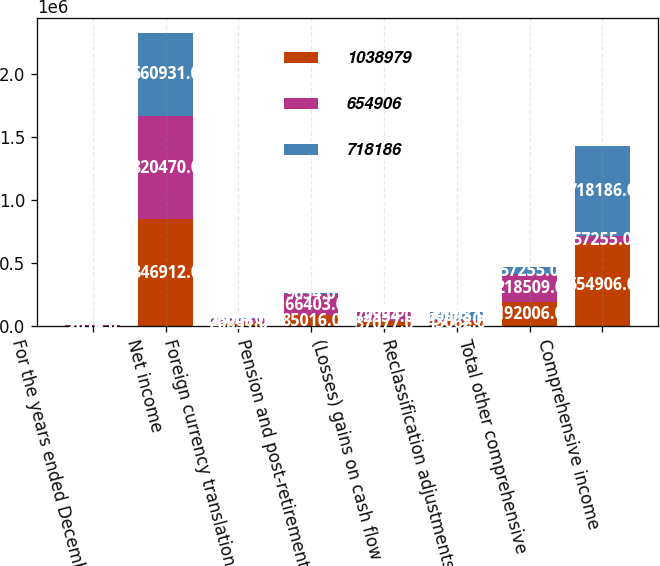Convert chart to OTSL. <chart><loc_0><loc_0><loc_500><loc_500><stacked_bar_chart><ecel><fcel>For the years ended December<fcel>Net income<fcel>Foreign currency translation<fcel>Pension and post-retirement<fcel>(Losses) gains on cash flow<fcel>Reclassification adjustments<fcel>Total other comprehensive<fcel>Comprehensive income<nl><fcel>1.03898e+06<fcel>2014<fcel>846912<fcel>26851<fcel>85016<fcel>37077<fcel>43062<fcel>192006<fcel>654906<nl><fcel>654906<fcel>2013<fcel>820470<fcel>26003<fcel>166403<fcel>72334<fcel>5775<fcel>218509<fcel>57255<nl><fcel>718186<fcel>2012<fcel>660931<fcel>7714<fcel>9634<fcel>868<fcel>60043<fcel>57255<fcel>718186<nl></chart> 